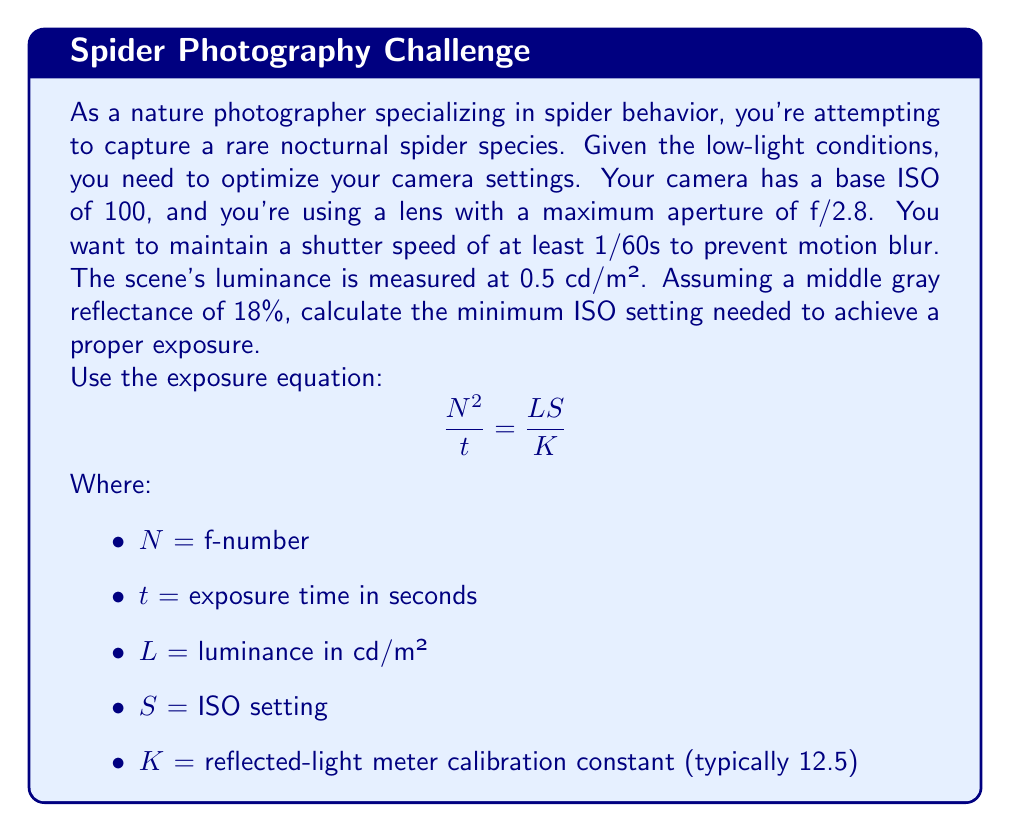Teach me how to tackle this problem. Let's approach this step-by-step:

1) We're given:
   - Luminance (L) = 0.5 cd/m²
   - Aperture (N) = f/2.8
   - Shutter speed (t) = 1/60s
   - Calibration constant (K) = 12.5

2) We need to find the minimum ISO (S) that satisfies the exposure equation.

3) Let's substitute the known values into the equation:

   $$\frac{2.8^2}{1/60} = \frac{0.5 \cdot S}{12.5}$$

4) Simplify the left side:
   
   $$2.8^2 \cdot 60 = \frac{0.5 \cdot S}{12.5}$$
   $$470.4 = \frac{0.5 \cdot S}{12.5}$$

5) Multiply both sides by 12.5:

   $$5880 = 0.5 \cdot S$$

6) Divide both sides by 0.5:

   $$11760 = S$$

7) Therefore, the minimum ISO setting needed is 11760. However, most cameras don't offer this exact ISO value. We need to round up to the nearest available ISO setting, which is typically 12800.
Answer: ISO 12800 